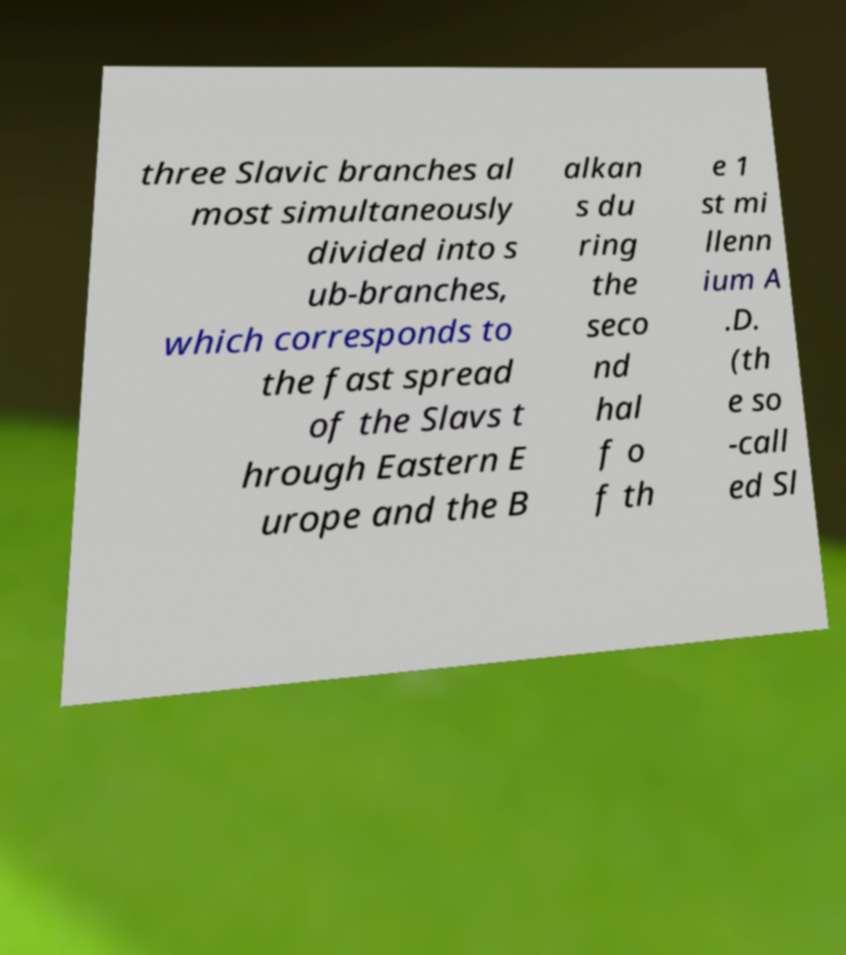Could you extract and type out the text from this image? three Slavic branches al most simultaneously divided into s ub-branches, which corresponds to the fast spread of the Slavs t hrough Eastern E urope and the B alkan s du ring the seco nd hal f o f th e 1 st mi llenn ium A .D. (th e so -call ed Sl 